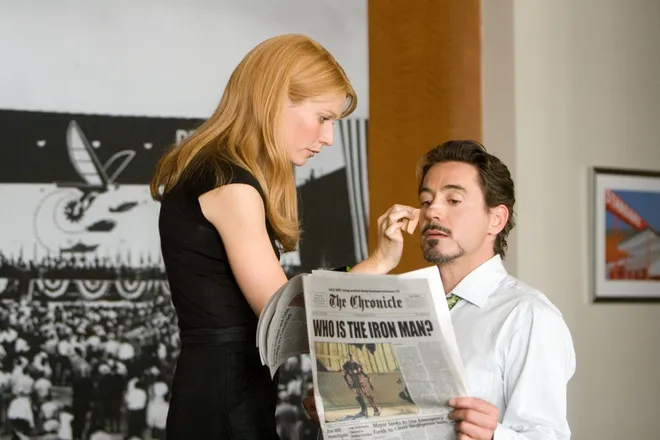What emotions do the characters' expressions convey in this image? In the image, Pepper Potts shows a combination of concern and tenderness in her expression, indicative of her care and close relationship with Tony Stark. Tony, on the other hand, appears introspective and somewhat troubled, likely reflecting his inner turmoil about his identity as Iron Man and the responsibilities it entails. 